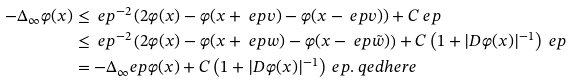<formula> <loc_0><loc_0><loc_500><loc_500>- \Delta _ { \infty } \varphi ( x ) & \leq \ e p ^ { - 2 } \left ( 2 \varphi ( x ) - \varphi ( x + \ e p v ) - \varphi ( x - \ e p v ) \right ) + C \ e p \\ & \leq \ e p ^ { - 2 } \left ( 2 \varphi ( x ) - \varphi ( x + \ e p w ) - \varphi ( x - \ e p \tilde { w } ) \right ) + C \left ( 1 + | D \varphi ( x ) | ^ { - 1 } \right ) \ e p \\ & = - \Delta _ { \infty } ^ { \ } e p \varphi ( x ) + C \left ( 1 + | D \varphi ( x ) | ^ { - 1 } \right ) \ e p . \ q e d h e r e</formula> 